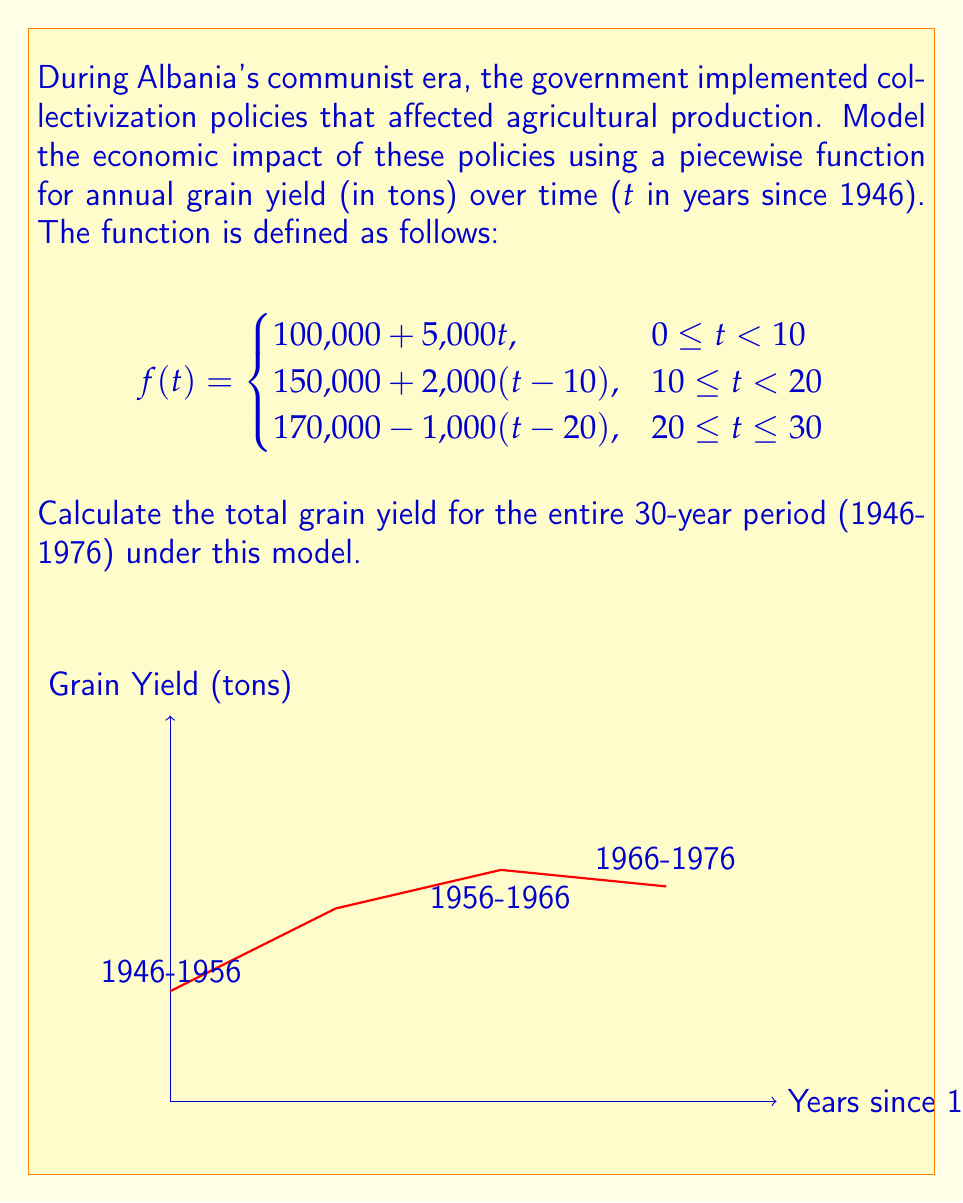Help me with this question. To calculate the total grain yield for the 30-year period, we need to find the area under the piecewise function. We can do this by integrating each piece of the function over its respective interval and then summing the results.

1. For $0 \leq t < 10$ (1946-1956):
   $$\int_0^{10} (100,000 + 5,000t) dt = [100,000t + 2,500t^2]_0^{10} = 1,250,000$$

2. For $10 \leq t < 20$ (1956-1966):
   $$\int_{10}^{20} (150,000 + 2,000(t-10)) dt = [150,000t + 1,000(t-10)^2]_{10}^{20} = 1,700,000$$

3. For $20 \leq t \leq 30$ (1966-1976):
   $$\int_{20}^{30} (170,000 - 1,000(t-20)) dt = [170,000t - 500(t-20)^2]_{20}^{30} = 1,650,000$$

4. Sum the results:
   Total yield = 1,250,000 + 1,700,000 + 1,650,000 = 4,600,000 tons
Answer: 4,600,000 tons 